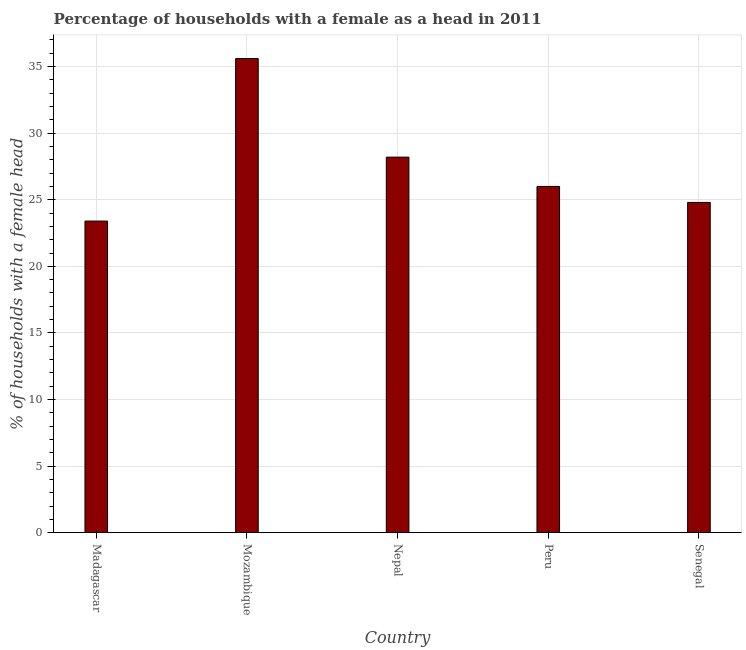What is the title of the graph?
Ensure brevity in your answer.  Percentage of households with a female as a head in 2011. What is the label or title of the Y-axis?
Provide a succinct answer. % of households with a female head. What is the number of female supervised households in Mozambique?
Your answer should be compact. 35.6. Across all countries, what is the maximum number of female supervised households?
Give a very brief answer. 35.6. Across all countries, what is the minimum number of female supervised households?
Ensure brevity in your answer.  23.4. In which country was the number of female supervised households maximum?
Offer a terse response. Mozambique. In which country was the number of female supervised households minimum?
Your response must be concise. Madagascar. What is the sum of the number of female supervised households?
Your answer should be compact. 138. What is the average number of female supervised households per country?
Provide a short and direct response. 27.6. What is the median number of female supervised households?
Make the answer very short. 26. What is the ratio of the number of female supervised households in Nepal to that in Senegal?
Offer a very short reply. 1.14. How many bars are there?
Give a very brief answer. 5. How many countries are there in the graph?
Offer a terse response. 5. What is the difference between two consecutive major ticks on the Y-axis?
Ensure brevity in your answer.  5. Are the values on the major ticks of Y-axis written in scientific E-notation?
Your answer should be compact. No. What is the % of households with a female head in Madagascar?
Provide a succinct answer. 23.4. What is the % of households with a female head in Mozambique?
Offer a very short reply. 35.6. What is the % of households with a female head in Nepal?
Offer a very short reply. 28.2. What is the % of households with a female head of Peru?
Your answer should be compact. 26. What is the % of households with a female head in Senegal?
Make the answer very short. 24.8. What is the difference between the % of households with a female head in Madagascar and Senegal?
Keep it short and to the point. -1.4. What is the difference between the % of households with a female head in Mozambique and Nepal?
Give a very brief answer. 7.4. What is the difference between the % of households with a female head in Mozambique and Peru?
Offer a very short reply. 9.6. What is the difference between the % of households with a female head in Mozambique and Senegal?
Your answer should be very brief. 10.8. What is the ratio of the % of households with a female head in Madagascar to that in Mozambique?
Provide a short and direct response. 0.66. What is the ratio of the % of households with a female head in Madagascar to that in Nepal?
Provide a short and direct response. 0.83. What is the ratio of the % of households with a female head in Madagascar to that in Peru?
Provide a short and direct response. 0.9. What is the ratio of the % of households with a female head in Madagascar to that in Senegal?
Offer a terse response. 0.94. What is the ratio of the % of households with a female head in Mozambique to that in Nepal?
Your answer should be very brief. 1.26. What is the ratio of the % of households with a female head in Mozambique to that in Peru?
Your answer should be very brief. 1.37. What is the ratio of the % of households with a female head in Mozambique to that in Senegal?
Keep it short and to the point. 1.44. What is the ratio of the % of households with a female head in Nepal to that in Peru?
Keep it short and to the point. 1.08. What is the ratio of the % of households with a female head in Nepal to that in Senegal?
Keep it short and to the point. 1.14. What is the ratio of the % of households with a female head in Peru to that in Senegal?
Ensure brevity in your answer.  1.05. 